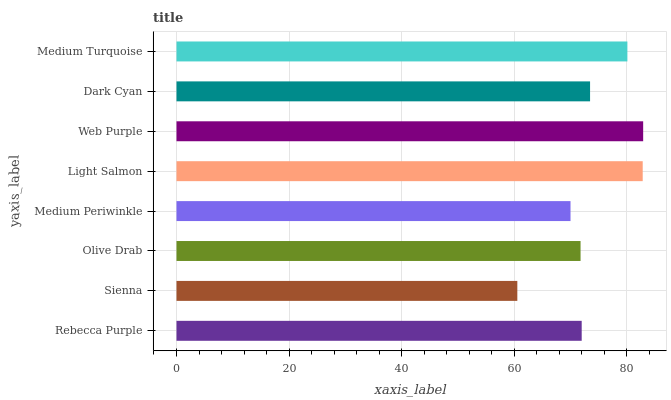Is Sienna the minimum?
Answer yes or no. Yes. Is Web Purple the maximum?
Answer yes or no. Yes. Is Olive Drab the minimum?
Answer yes or no. No. Is Olive Drab the maximum?
Answer yes or no. No. Is Olive Drab greater than Sienna?
Answer yes or no. Yes. Is Sienna less than Olive Drab?
Answer yes or no. Yes. Is Sienna greater than Olive Drab?
Answer yes or no. No. Is Olive Drab less than Sienna?
Answer yes or no. No. Is Dark Cyan the high median?
Answer yes or no. Yes. Is Rebecca Purple the low median?
Answer yes or no. Yes. Is Olive Drab the high median?
Answer yes or no. No. Is Olive Drab the low median?
Answer yes or no. No. 